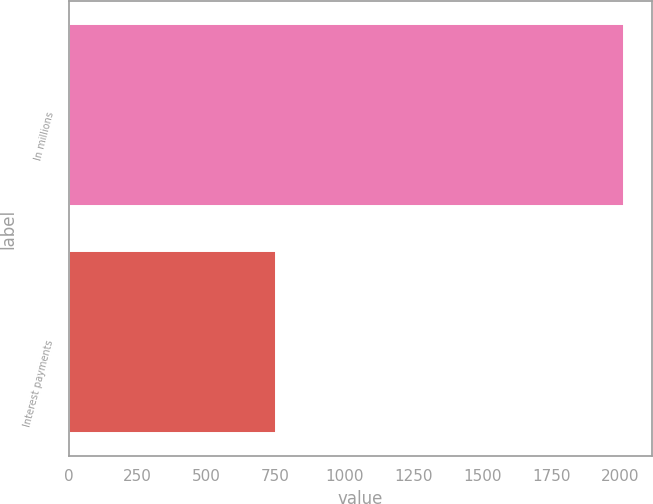Convert chart. <chart><loc_0><loc_0><loc_500><loc_500><bar_chart><fcel>In millions<fcel>Interest payments<nl><fcel>2013<fcel>751<nl></chart> 